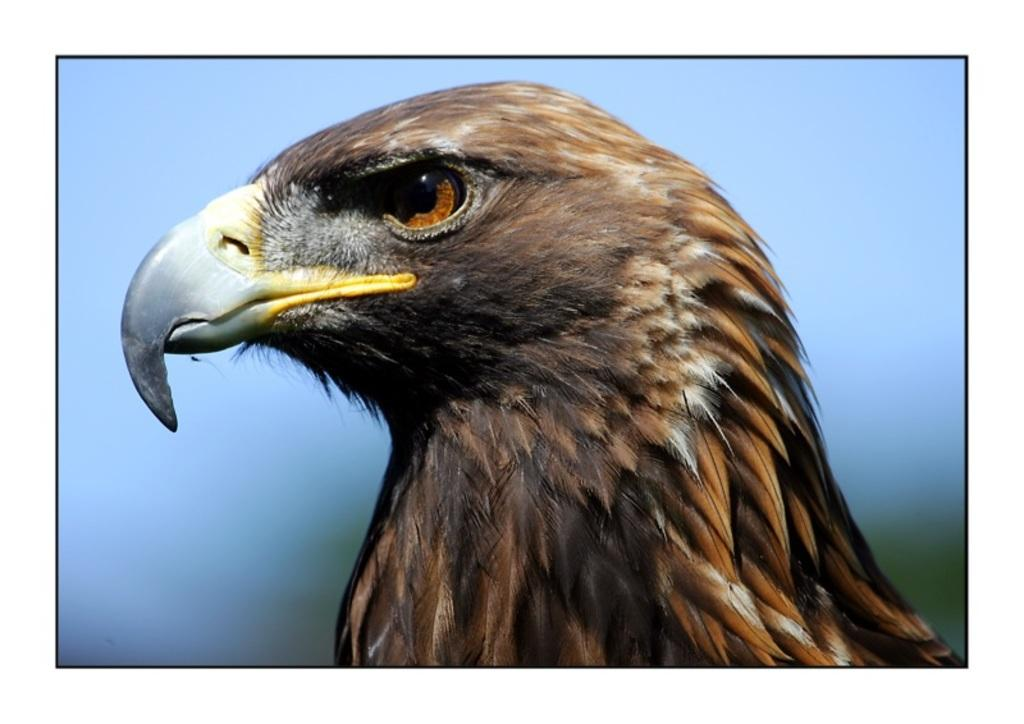What can be observed about the image's appearance? The image is edited, and there is an eagle's face in the image. How does the background of the image look? The background appears blurry. What type of competition is the eagle participating in within the image? There is no competition present in the image; it only features an eagle's face with a blurry background. 